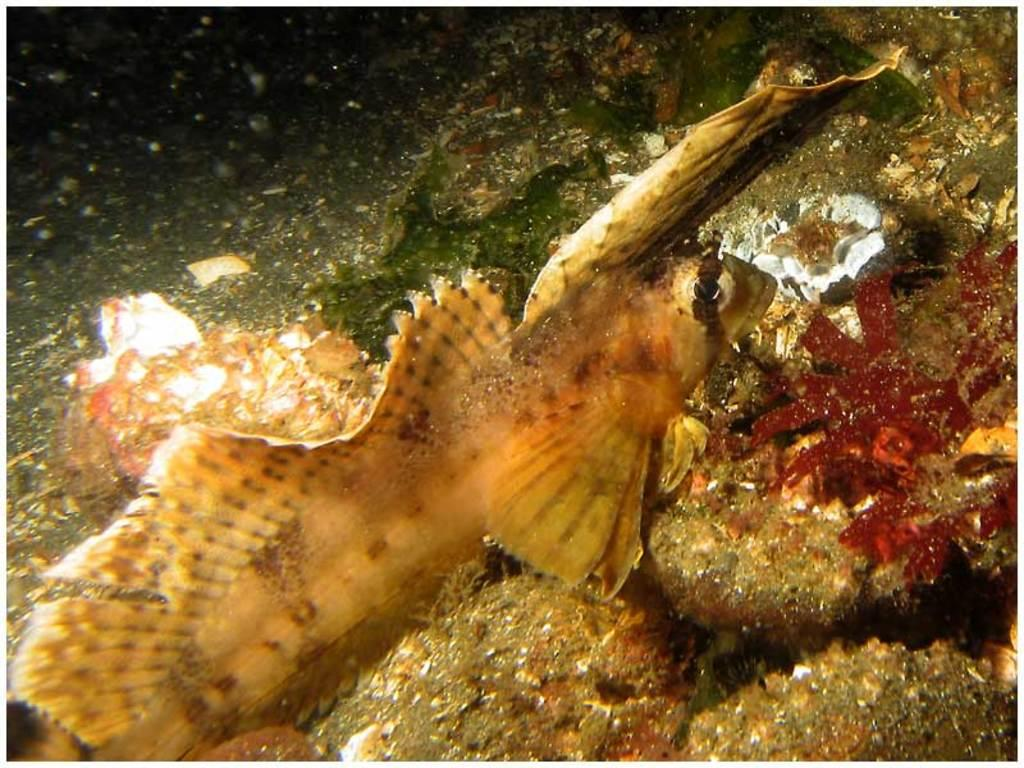What type of animal is in the image? There is a fish in the image. What is the environment in which the fish is located? The fish is in the water in the image. Are there any other objects or creatures in the water with the fish? Yes, there are other objects in the water in the image. How does the fish breathe underwater in the image? The image does not show the fish breathing, but fish typically breathe underwater using gills. What type of bun is being used to feed the fish in the image? There is no bun present in the image; the fish is in the water with other objects. 